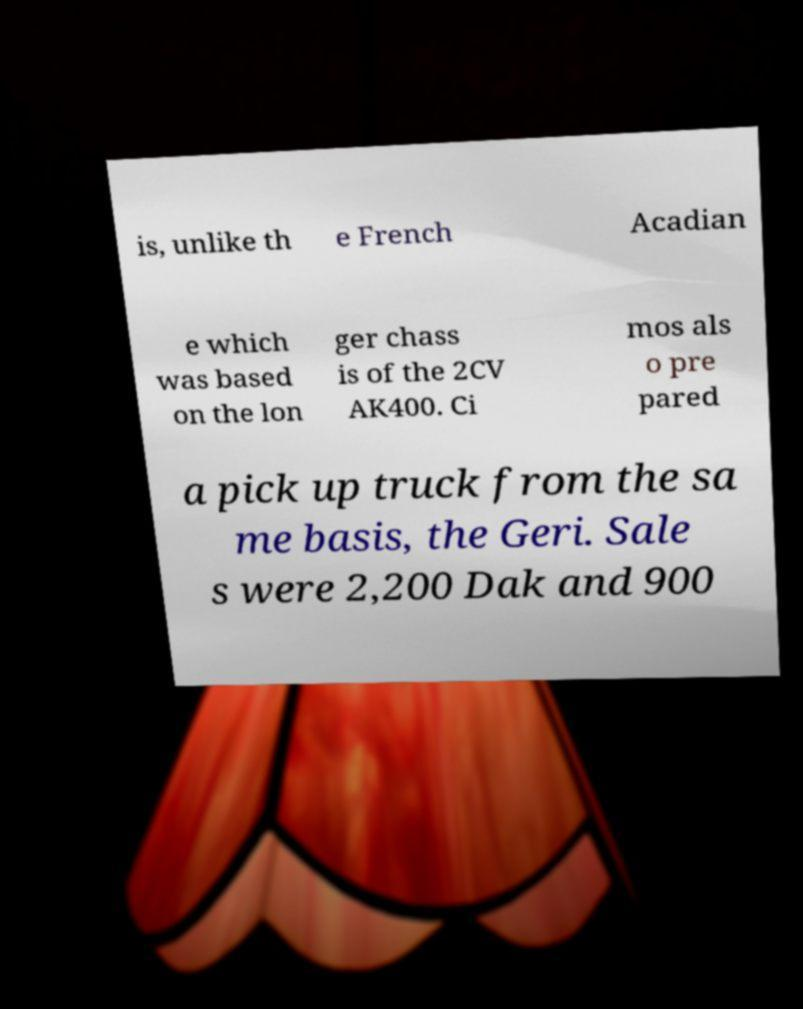Can you accurately transcribe the text from the provided image for me? is, unlike th e French Acadian e which was based on the lon ger chass is of the 2CV AK400. Ci mos als o pre pared a pick up truck from the sa me basis, the Geri. Sale s were 2,200 Dak and 900 